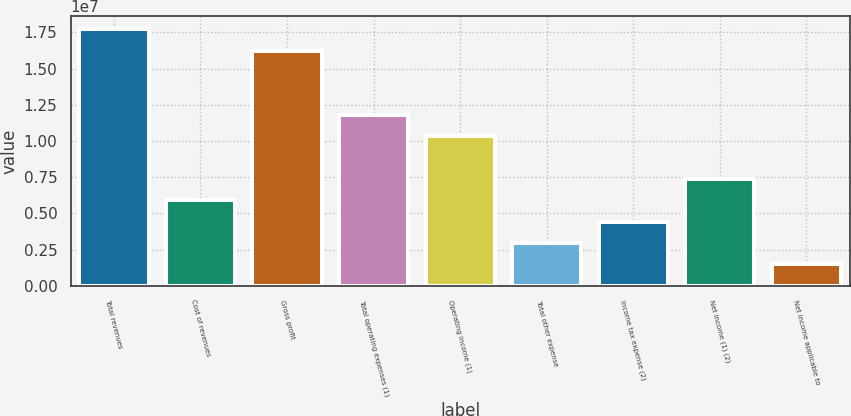Convert chart. <chart><loc_0><loc_0><loc_500><loc_500><bar_chart><fcel>Total revenues<fcel>Cost of revenues<fcel>Gross profit<fcel>Total operating expenses (1)<fcel>Operating income (1)<fcel>Total other expense<fcel>Income tax expense (2)<fcel>Net income (1) (2)<fcel>Net income applicable to<nl><fcel>1.77252e+07<fcel>5.90842e+06<fcel>1.62481e+07<fcel>1.18168e+07<fcel>1.03397e+07<fcel>2.95423e+06<fcel>4.43133e+06<fcel>7.38551e+06<fcel>1.47714e+06<nl></chart> 